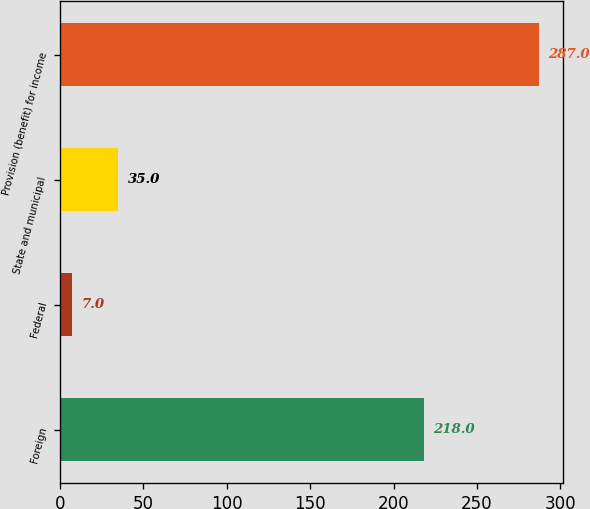<chart> <loc_0><loc_0><loc_500><loc_500><bar_chart><fcel>Foreign<fcel>Federal<fcel>State and municipal<fcel>Provision (benefit) for income<nl><fcel>218<fcel>7<fcel>35<fcel>287<nl></chart> 